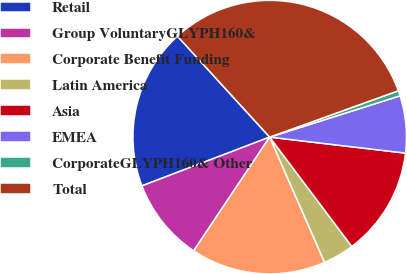<chart> <loc_0><loc_0><loc_500><loc_500><pie_chart><fcel>Retail<fcel>Group VoluntaryGLYPH160&<fcel>Corporate Benefit Funding<fcel>Latin America<fcel>Asia<fcel>EMEA<fcel>CorporateGLYPH160& Other<fcel>Total<nl><fcel>19.02%<fcel>9.82%<fcel>15.95%<fcel>3.68%<fcel>12.88%<fcel>6.75%<fcel>0.62%<fcel>31.28%<nl></chart> 